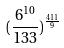<formula> <loc_0><loc_0><loc_500><loc_500>( \frac { 6 ^ { 1 0 } } { 1 3 3 } ) ^ { \frac { 4 1 1 } { 9 } }</formula> 